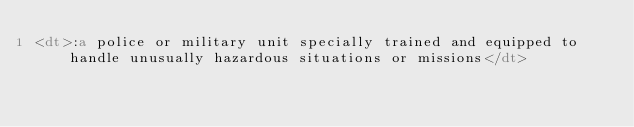Convert code to text. <code><loc_0><loc_0><loc_500><loc_500><_HTML_><dt>:a police or military unit specially trained and equipped to handle unusually hazardous situations or missions</dt>
</code> 